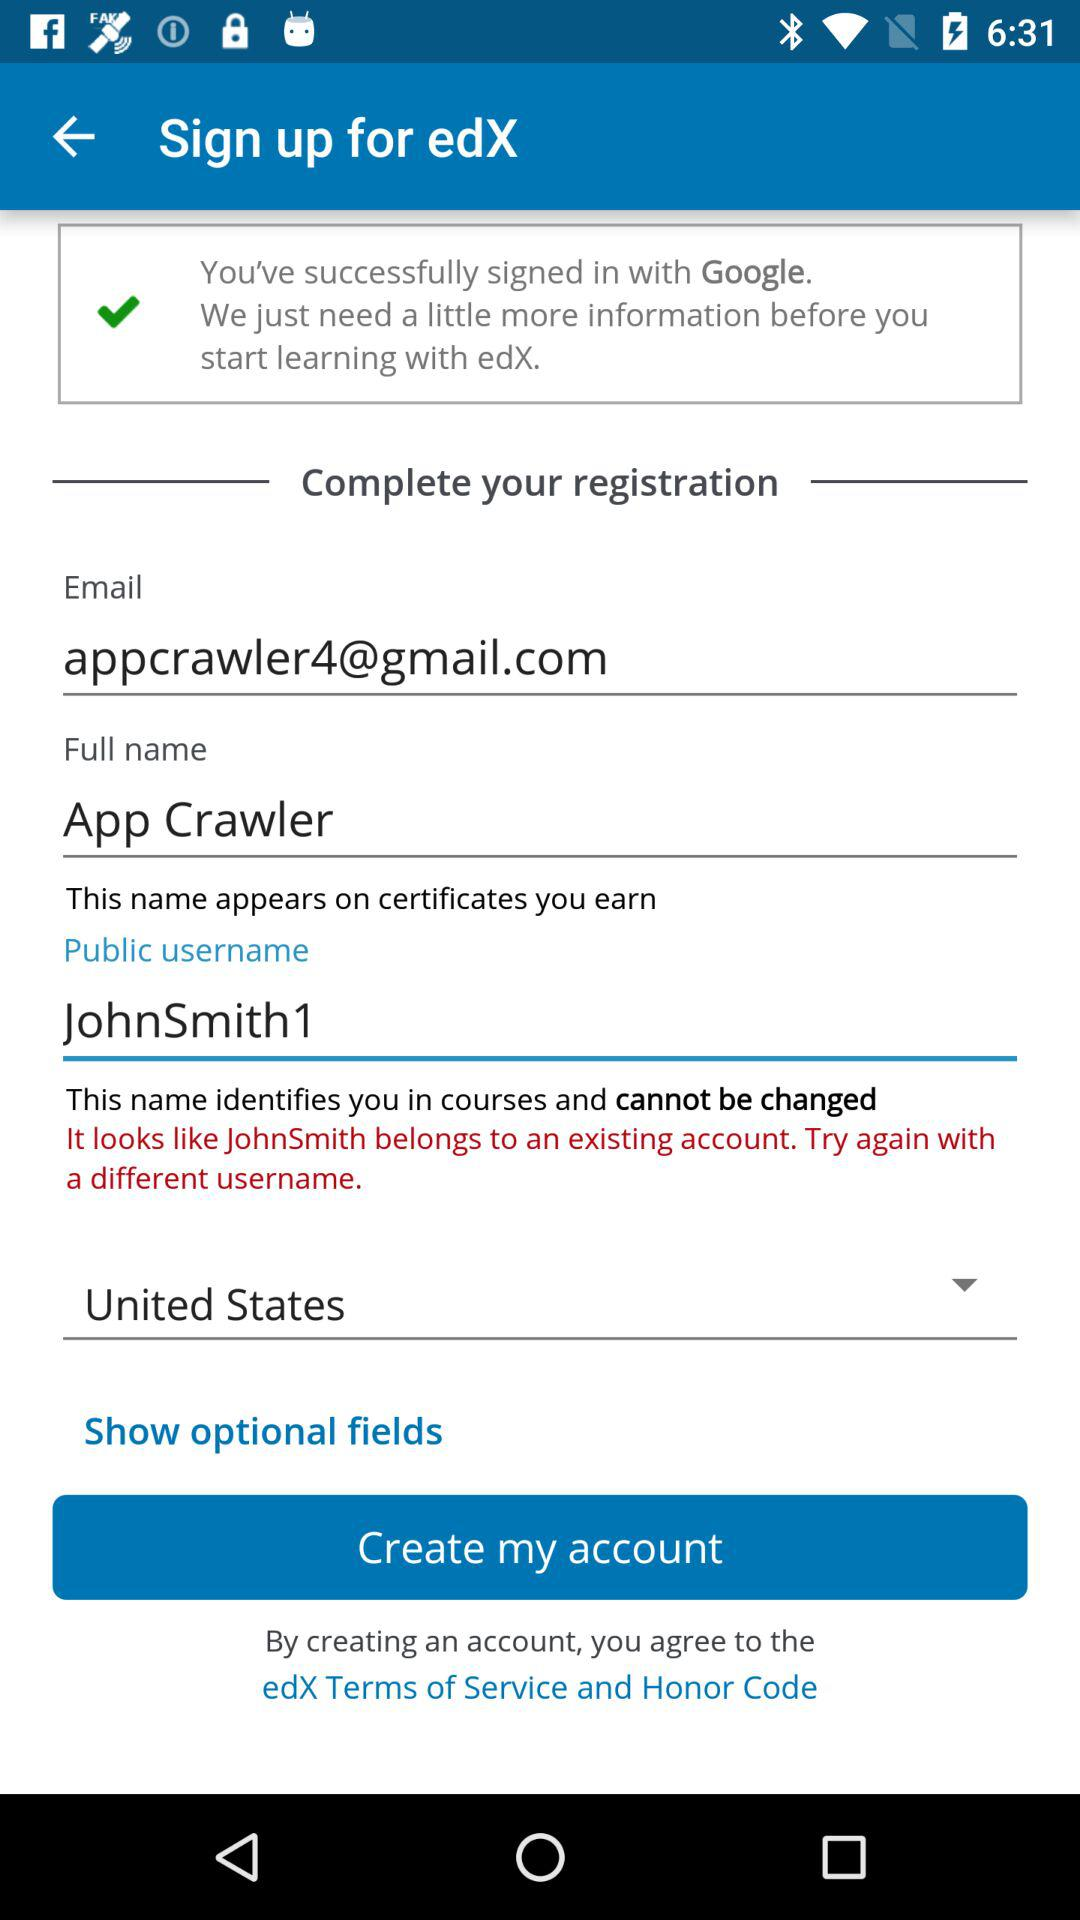How many text inputs are required to create an account?
Answer the question using a single word or phrase. 3 